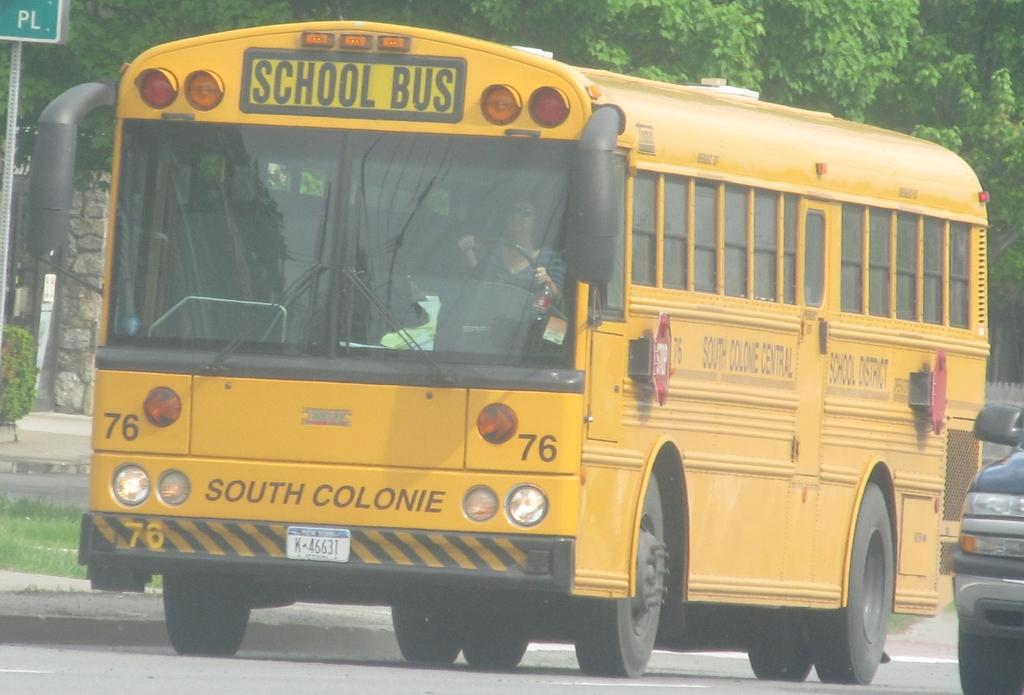<image>
Relay a brief, clear account of the picture shown. A school bus showing the driver inside, driving through a neighborhood street. 